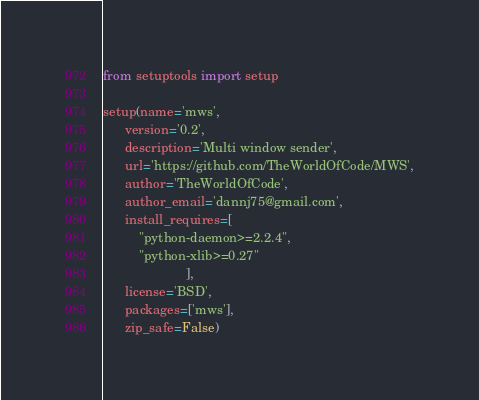Convert code to text. <code><loc_0><loc_0><loc_500><loc_500><_Python_>
from setuptools import setup

setup(name='mws',
      version='0.2',
      description='Multi window sender',
      url='https://github.com/TheWorldOfCode/MWS',
      author='TheWorldOfCode',
      author_email='dannj75@gmail.com',
      install_requires=[
          "python-daemon>=2.2.4",
          "python-xlib>=0.27"
                       ],
      license='BSD',
      packages=['mws'],
      zip_safe=False)
</code> 